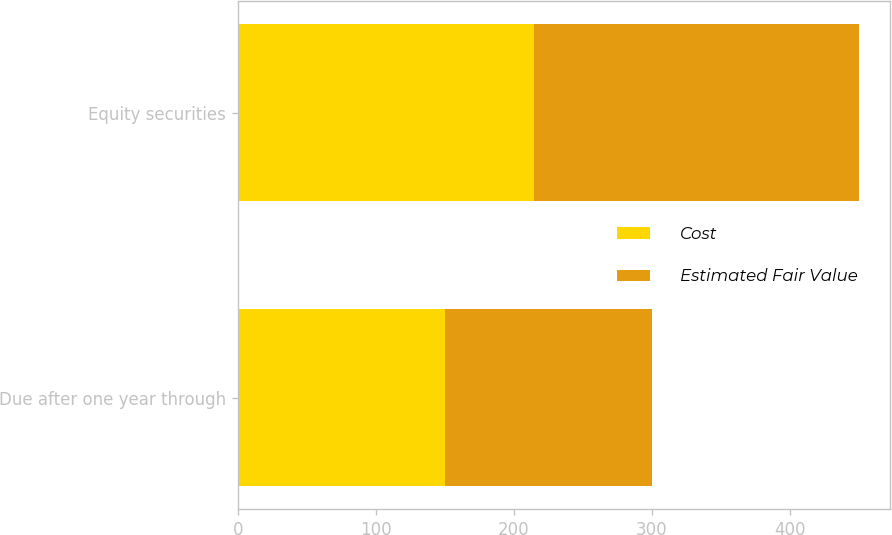Convert chart to OTSL. <chart><loc_0><loc_0><loc_500><loc_500><stacked_bar_chart><ecel><fcel>Due after one year through<fcel>Equity securities<nl><fcel>Cost<fcel>150<fcel>215<nl><fcel>Estimated Fair Value<fcel>150<fcel>235<nl></chart> 